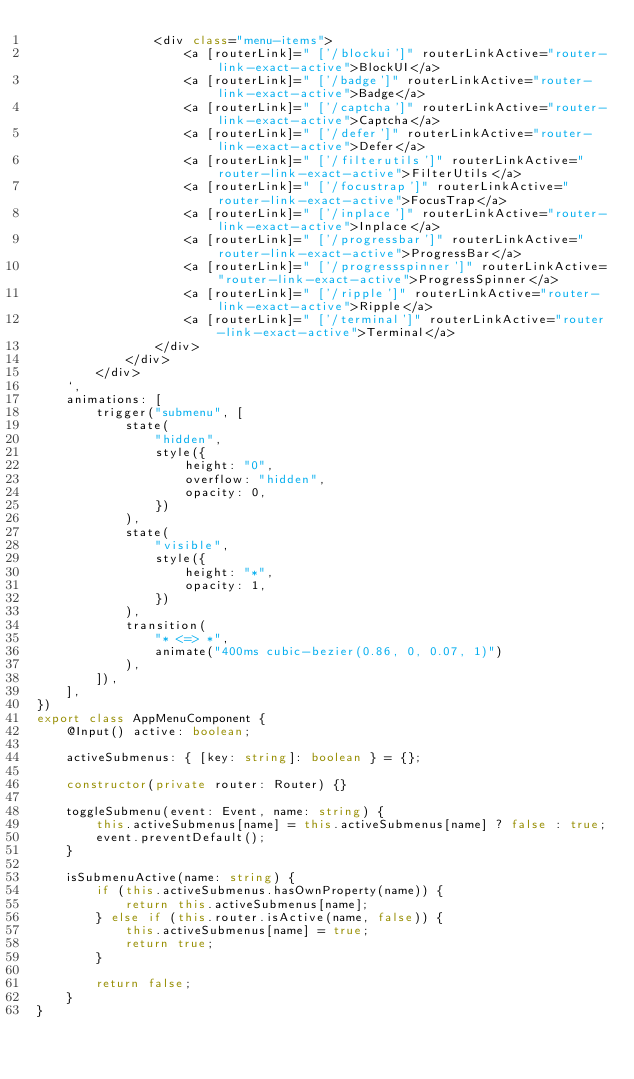<code> <loc_0><loc_0><loc_500><loc_500><_TypeScript_>                <div class="menu-items">
                    <a [routerLink]=" ['/blockui']" routerLinkActive="router-link-exact-active">BlockUI</a>
                    <a [routerLink]=" ['/badge']" routerLinkActive="router-link-exact-active">Badge</a>
                    <a [routerLink]=" ['/captcha']" routerLinkActive="router-link-exact-active">Captcha</a>
                    <a [routerLink]=" ['/defer']" routerLinkActive="router-link-exact-active">Defer</a>
                    <a [routerLink]=" ['/filterutils']" routerLinkActive="router-link-exact-active">FilterUtils</a>
                    <a [routerLink]=" ['/focustrap']" routerLinkActive="router-link-exact-active">FocusTrap</a>
                    <a [routerLink]=" ['/inplace']" routerLinkActive="router-link-exact-active">Inplace</a>
                    <a [routerLink]=" ['/progressbar']" routerLinkActive="router-link-exact-active">ProgressBar</a>
                    <a [routerLink]=" ['/progressspinner']" routerLinkActive="router-link-exact-active">ProgressSpinner</a>
                    <a [routerLink]=" ['/ripple']" routerLinkActive="router-link-exact-active">Ripple</a>
                    <a [routerLink]=" ['/terminal']" routerLinkActive="router-link-exact-active">Terminal</a>
                </div>
            </div>
        </div>
    `,
    animations: [
        trigger("submenu", [
            state(
                "hidden",
                style({
                    height: "0",
                    overflow: "hidden",
                    opacity: 0,
                })
            ),
            state(
                "visible",
                style({
                    height: "*",
                    opacity: 1,
                })
            ),
            transition(
                "* <=> *",
                animate("400ms cubic-bezier(0.86, 0, 0.07, 1)")
            ),
        ]),
    ],
})
export class AppMenuComponent {
    @Input() active: boolean;

    activeSubmenus: { [key: string]: boolean } = {};

    constructor(private router: Router) {}

    toggleSubmenu(event: Event, name: string) {
        this.activeSubmenus[name] = this.activeSubmenus[name] ? false : true;
        event.preventDefault();
    }

    isSubmenuActive(name: string) {
        if (this.activeSubmenus.hasOwnProperty(name)) {
            return this.activeSubmenus[name];
        } else if (this.router.isActive(name, false)) {
            this.activeSubmenus[name] = true;
            return true;
        }

        return false;
    }
}
</code> 